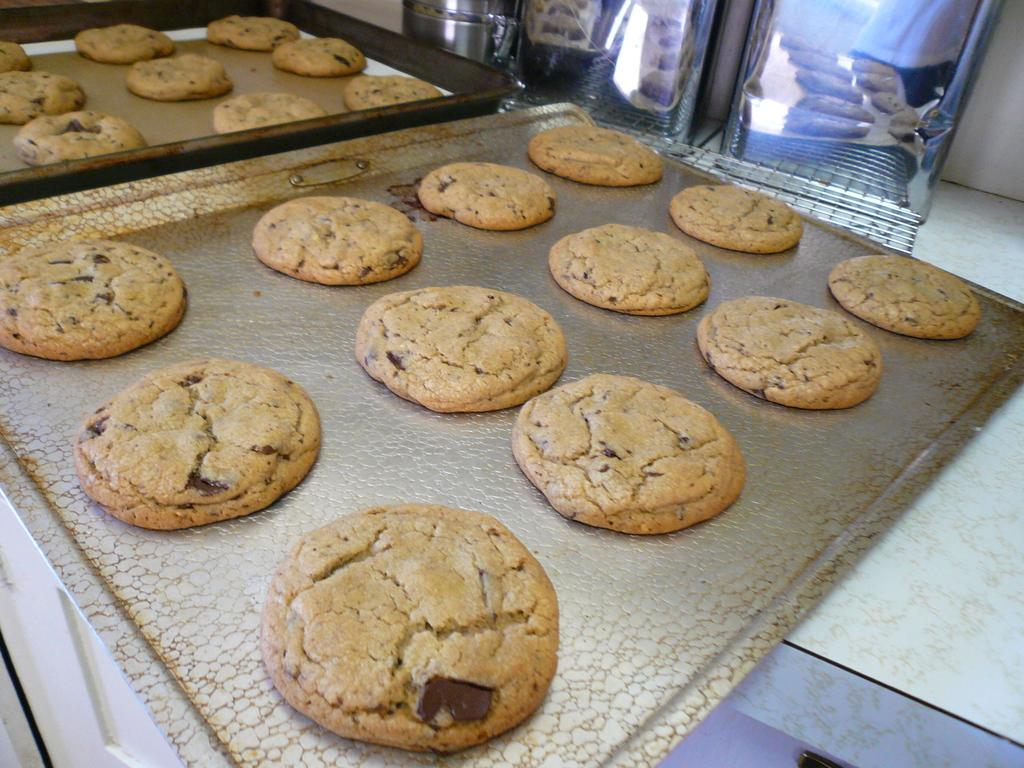What type of food can be seen in the image? There are biscuits in the image. What are the biscuits placed on or in? The biscuits are on objects. Can you see a typewriter in the image? There is no typewriter present in the image. Is the image taken near the ocean? There is no indication of the ocean or any water body in the image. 